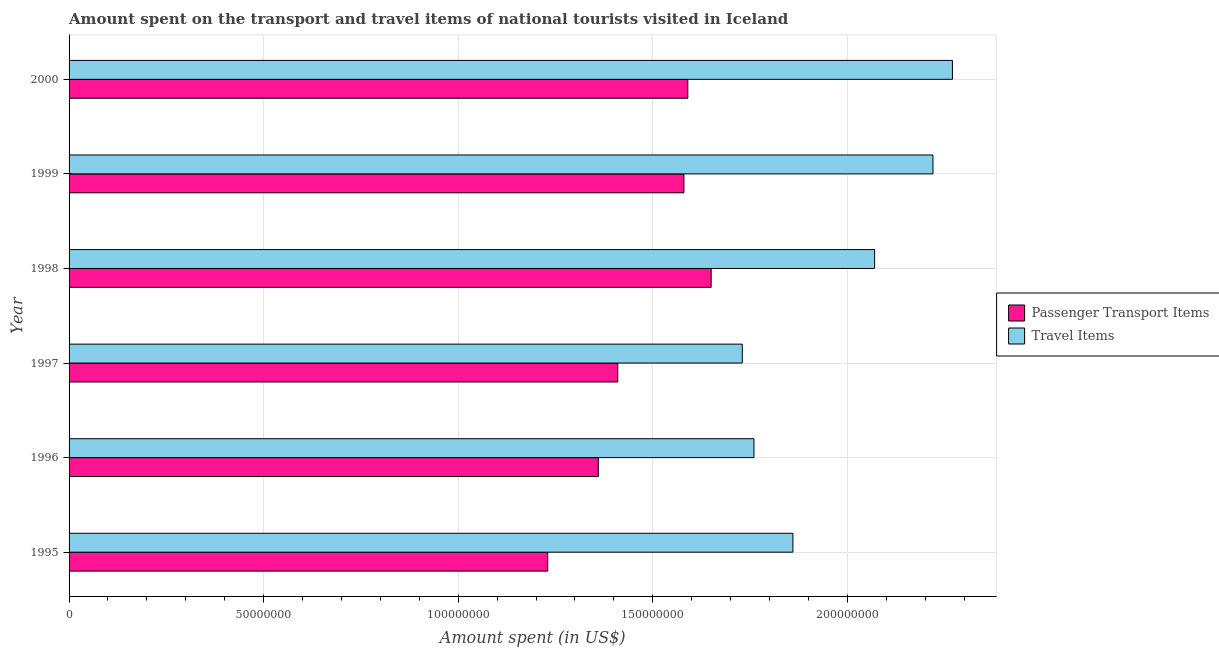How many different coloured bars are there?
Give a very brief answer. 2. Are the number of bars per tick equal to the number of legend labels?
Give a very brief answer. Yes. What is the label of the 1st group of bars from the top?
Your response must be concise. 2000. In how many cases, is the number of bars for a given year not equal to the number of legend labels?
Your answer should be compact. 0. What is the amount spent in travel items in 1997?
Provide a succinct answer. 1.73e+08. Across all years, what is the maximum amount spent in travel items?
Ensure brevity in your answer.  2.27e+08. Across all years, what is the minimum amount spent in travel items?
Make the answer very short. 1.73e+08. In which year was the amount spent in travel items maximum?
Provide a succinct answer. 2000. In which year was the amount spent on passenger transport items minimum?
Your answer should be compact. 1995. What is the total amount spent in travel items in the graph?
Your response must be concise. 1.19e+09. What is the difference between the amount spent in travel items in 1995 and that in 1999?
Provide a short and direct response. -3.60e+07. What is the difference between the amount spent in travel items in 1995 and the amount spent on passenger transport items in 1996?
Provide a short and direct response. 5.00e+07. What is the average amount spent on passenger transport items per year?
Offer a terse response. 1.47e+08. In the year 1995, what is the difference between the amount spent on passenger transport items and amount spent in travel items?
Give a very brief answer. -6.30e+07. In how many years, is the amount spent on passenger transport items greater than 70000000 US$?
Provide a succinct answer. 6. What is the ratio of the amount spent on passenger transport items in 1996 to that in 1999?
Keep it short and to the point. 0.86. Is the amount spent in travel items in 1999 less than that in 2000?
Provide a succinct answer. Yes. What is the difference between the highest and the second highest amount spent in travel items?
Offer a very short reply. 5.00e+06. What is the difference between the highest and the lowest amount spent in travel items?
Give a very brief answer. 5.40e+07. Is the sum of the amount spent on passenger transport items in 1995 and 1997 greater than the maximum amount spent in travel items across all years?
Make the answer very short. Yes. What does the 2nd bar from the top in 1995 represents?
Offer a terse response. Passenger Transport Items. What does the 2nd bar from the bottom in 1999 represents?
Your answer should be compact. Travel Items. Are all the bars in the graph horizontal?
Provide a short and direct response. Yes. Are the values on the major ticks of X-axis written in scientific E-notation?
Provide a short and direct response. No. Does the graph contain any zero values?
Provide a short and direct response. No. Does the graph contain grids?
Offer a very short reply. Yes. Where does the legend appear in the graph?
Provide a short and direct response. Center right. How many legend labels are there?
Ensure brevity in your answer.  2. How are the legend labels stacked?
Provide a succinct answer. Vertical. What is the title of the graph?
Give a very brief answer. Amount spent on the transport and travel items of national tourists visited in Iceland. What is the label or title of the X-axis?
Give a very brief answer. Amount spent (in US$). What is the Amount spent (in US$) of Passenger Transport Items in 1995?
Make the answer very short. 1.23e+08. What is the Amount spent (in US$) in Travel Items in 1995?
Your answer should be compact. 1.86e+08. What is the Amount spent (in US$) of Passenger Transport Items in 1996?
Offer a very short reply. 1.36e+08. What is the Amount spent (in US$) in Travel Items in 1996?
Your answer should be very brief. 1.76e+08. What is the Amount spent (in US$) in Passenger Transport Items in 1997?
Offer a terse response. 1.41e+08. What is the Amount spent (in US$) in Travel Items in 1997?
Provide a short and direct response. 1.73e+08. What is the Amount spent (in US$) in Passenger Transport Items in 1998?
Offer a very short reply. 1.65e+08. What is the Amount spent (in US$) in Travel Items in 1998?
Offer a very short reply. 2.07e+08. What is the Amount spent (in US$) of Passenger Transport Items in 1999?
Offer a terse response. 1.58e+08. What is the Amount spent (in US$) of Travel Items in 1999?
Ensure brevity in your answer.  2.22e+08. What is the Amount spent (in US$) of Passenger Transport Items in 2000?
Offer a very short reply. 1.59e+08. What is the Amount spent (in US$) of Travel Items in 2000?
Give a very brief answer. 2.27e+08. Across all years, what is the maximum Amount spent (in US$) in Passenger Transport Items?
Provide a short and direct response. 1.65e+08. Across all years, what is the maximum Amount spent (in US$) in Travel Items?
Provide a succinct answer. 2.27e+08. Across all years, what is the minimum Amount spent (in US$) of Passenger Transport Items?
Make the answer very short. 1.23e+08. Across all years, what is the minimum Amount spent (in US$) in Travel Items?
Your answer should be very brief. 1.73e+08. What is the total Amount spent (in US$) of Passenger Transport Items in the graph?
Offer a terse response. 8.82e+08. What is the total Amount spent (in US$) of Travel Items in the graph?
Keep it short and to the point. 1.19e+09. What is the difference between the Amount spent (in US$) of Passenger Transport Items in 1995 and that in 1996?
Make the answer very short. -1.30e+07. What is the difference between the Amount spent (in US$) of Travel Items in 1995 and that in 1996?
Make the answer very short. 1.00e+07. What is the difference between the Amount spent (in US$) of Passenger Transport Items in 1995 and that in 1997?
Provide a short and direct response. -1.80e+07. What is the difference between the Amount spent (in US$) in Travel Items in 1995 and that in 1997?
Keep it short and to the point. 1.30e+07. What is the difference between the Amount spent (in US$) of Passenger Transport Items in 1995 and that in 1998?
Your answer should be very brief. -4.20e+07. What is the difference between the Amount spent (in US$) of Travel Items in 1995 and that in 1998?
Offer a very short reply. -2.10e+07. What is the difference between the Amount spent (in US$) in Passenger Transport Items in 1995 and that in 1999?
Keep it short and to the point. -3.50e+07. What is the difference between the Amount spent (in US$) in Travel Items in 1995 and that in 1999?
Keep it short and to the point. -3.60e+07. What is the difference between the Amount spent (in US$) in Passenger Transport Items in 1995 and that in 2000?
Ensure brevity in your answer.  -3.60e+07. What is the difference between the Amount spent (in US$) of Travel Items in 1995 and that in 2000?
Your answer should be compact. -4.10e+07. What is the difference between the Amount spent (in US$) in Passenger Transport Items in 1996 and that in 1997?
Offer a terse response. -5.00e+06. What is the difference between the Amount spent (in US$) in Passenger Transport Items in 1996 and that in 1998?
Ensure brevity in your answer.  -2.90e+07. What is the difference between the Amount spent (in US$) of Travel Items in 1996 and that in 1998?
Give a very brief answer. -3.10e+07. What is the difference between the Amount spent (in US$) of Passenger Transport Items in 1996 and that in 1999?
Give a very brief answer. -2.20e+07. What is the difference between the Amount spent (in US$) in Travel Items in 1996 and that in 1999?
Keep it short and to the point. -4.60e+07. What is the difference between the Amount spent (in US$) of Passenger Transport Items in 1996 and that in 2000?
Your answer should be very brief. -2.30e+07. What is the difference between the Amount spent (in US$) in Travel Items in 1996 and that in 2000?
Your response must be concise. -5.10e+07. What is the difference between the Amount spent (in US$) in Passenger Transport Items in 1997 and that in 1998?
Offer a very short reply. -2.40e+07. What is the difference between the Amount spent (in US$) in Travel Items in 1997 and that in 1998?
Offer a terse response. -3.40e+07. What is the difference between the Amount spent (in US$) of Passenger Transport Items in 1997 and that in 1999?
Your answer should be very brief. -1.70e+07. What is the difference between the Amount spent (in US$) in Travel Items in 1997 and that in 1999?
Ensure brevity in your answer.  -4.90e+07. What is the difference between the Amount spent (in US$) in Passenger Transport Items in 1997 and that in 2000?
Make the answer very short. -1.80e+07. What is the difference between the Amount spent (in US$) of Travel Items in 1997 and that in 2000?
Make the answer very short. -5.40e+07. What is the difference between the Amount spent (in US$) of Passenger Transport Items in 1998 and that in 1999?
Offer a terse response. 7.00e+06. What is the difference between the Amount spent (in US$) of Travel Items in 1998 and that in 1999?
Make the answer very short. -1.50e+07. What is the difference between the Amount spent (in US$) of Passenger Transport Items in 1998 and that in 2000?
Your answer should be compact. 6.00e+06. What is the difference between the Amount spent (in US$) of Travel Items in 1998 and that in 2000?
Ensure brevity in your answer.  -2.00e+07. What is the difference between the Amount spent (in US$) in Travel Items in 1999 and that in 2000?
Ensure brevity in your answer.  -5.00e+06. What is the difference between the Amount spent (in US$) of Passenger Transport Items in 1995 and the Amount spent (in US$) of Travel Items in 1996?
Give a very brief answer. -5.30e+07. What is the difference between the Amount spent (in US$) in Passenger Transport Items in 1995 and the Amount spent (in US$) in Travel Items in 1997?
Your response must be concise. -5.00e+07. What is the difference between the Amount spent (in US$) in Passenger Transport Items in 1995 and the Amount spent (in US$) in Travel Items in 1998?
Your answer should be very brief. -8.40e+07. What is the difference between the Amount spent (in US$) of Passenger Transport Items in 1995 and the Amount spent (in US$) of Travel Items in 1999?
Make the answer very short. -9.90e+07. What is the difference between the Amount spent (in US$) in Passenger Transport Items in 1995 and the Amount spent (in US$) in Travel Items in 2000?
Offer a very short reply. -1.04e+08. What is the difference between the Amount spent (in US$) of Passenger Transport Items in 1996 and the Amount spent (in US$) of Travel Items in 1997?
Ensure brevity in your answer.  -3.70e+07. What is the difference between the Amount spent (in US$) of Passenger Transport Items in 1996 and the Amount spent (in US$) of Travel Items in 1998?
Your answer should be very brief. -7.10e+07. What is the difference between the Amount spent (in US$) of Passenger Transport Items in 1996 and the Amount spent (in US$) of Travel Items in 1999?
Offer a terse response. -8.60e+07. What is the difference between the Amount spent (in US$) in Passenger Transport Items in 1996 and the Amount spent (in US$) in Travel Items in 2000?
Your answer should be very brief. -9.10e+07. What is the difference between the Amount spent (in US$) of Passenger Transport Items in 1997 and the Amount spent (in US$) of Travel Items in 1998?
Make the answer very short. -6.60e+07. What is the difference between the Amount spent (in US$) of Passenger Transport Items in 1997 and the Amount spent (in US$) of Travel Items in 1999?
Make the answer very short. -8.10e+07. What is the difference between the Amount spent (in US$) in Passenger Transport Items in 1997 and the Amount spent (in US$) in Travel Items in 2000?
Give a very brief answer. -8.60e+07. What is the difference between the Amount spent (in US$) of Passenger Transport Items in 1998 and the Amount spent (in US$) of Travel Items in 1999?
Offer a very short reply. -5.70e+07. What is the difference between the Amount spent (in US$) of Passenger Transport Items in 1998 and the Amount spent (in US$) of Travel Items in 2000?
Keep it short and to the point. -6.20e+07. What is the difference between the Amount spent (in US$) in Passenger Transport Items in 1999 and the Amount spent (in US$) in Travel Items in 2000?
Offer a terse response. -6.90e+07. What is the average Amount spent (in US$) in Passenger Transport Items per year?
Provide a succinct answer. 1.47e+08. What is the average Amount spent (in US$) of Travel Items per year?
Keep it short and to the point. 1.98e+08. In the year 1995, what is the difference between the Amount spent (in US$) of Passenger Transport Items and Amount spent (in US$) of Travel Items?
Make the answer very short. -6.30e+07. In the year 1996, what is the difference between the Amount spent (in US$) in Passenger Transport Items and Amount spent (in US$) in Travel Items?
Your response must be concise. -4.00e+07. In the year 1997, what is the difference between the Amount spent (in US$) in Passenger Transport Items and Amount spent (in US$) in Travel Items?
Your answer should be compact. -3.20e+07. In the year 1998, what is the difference between the Amount spent (in US$) of Passenger Transport Items and Amount spent (in US$) of Travel Items?
Your answer should be very brief. -4.20e+07. In the year 1999, what is the difference between the Amount spent (in US$) in Passenger Transport Items and Amount spent (in US$) in Travel Items?
Offer a terse response. -6.40e+07. In the year 2000, what is the difference between the Amount spent (in US$) in Passenger Transport Items and Amount spent (in US$) in Travel Items?
Keep it short and to the point. -6.80e+07. What is the ratio of the Amount spent (in US$) of Passenger Transport Items in 1995 to that in 1996?
Provide a succinct answer. 0.9. What is the ratio of the Amount spent (in US$) in Travel Items in 1995 to that in 1996?
Give a very brief answer. 1.06. What is the ratio of the Amount spent (in US$) in Passenger Transport Items in 1995 to that in 1997?
Give a very brief answer. 0.87. What is the ratio of the Amount spent (in US$) of Travel Items in 1995 to that in 1997?
Keep it short and to the point. 1.08. What is the ratio of the Amount spent (in US$) in Passenger Transport Items in 1995 to that in 1998?
Offer a very short reply. 0.75. What is the ratio of the Amount spent (in US$) of Travel Items in 1995 to that in 1998?
Your answer should be compact. 0.9. What is the ratio of the Amount spent (in US$) in Passenger Transport Items in 1995 to that in 1999?
Make the answer very short. 0.78. What is the ratio of the Amount spent (in US$) of Travel Items in 1995 to that in 1999?
Give a very brief answer. 0.84. What is the ratio of the Amount spent (in US$) of Passenger Transport Items in 1995 to that in 2000?
Offer a very short reply. 0.77. What is the ratio of the Amount spent (in US$) of Travel Items in 1995 to that in 2000?
Offer a terse response. 0.82. What is the ratio of the Amount spent (in US$) of Passenger Transport Items in 1996 to that in 1997?
Offer a very short reply. 0.96. What is the ratio of the Amount spent (in US$) in Travel Items in 1996 to that in 1997?
Provide a succinct answer. 1.02. What is the ratio of the Amount spent (in US$) in Passenger Transport Items in 1996 to that in 1998?
Give a very brief answer. 0.82. What is the ratio of the Amount spent (in US$) of Travel Items in 1996 to that in 1998?
Provide a succinct answer. 0.85. What is the ratio of the Amount spent (in US$) of Passenger Transport Items in 1996 to that in 1999?
Your answer should be very brief. 0.86. What is the ratio of the Amount spent (in US$) of Travel Items in 1996 to that in 1999?
Provide a short and direct response. 0.79. What is the ratio of the Amount spent (in US$) of Passenger Transport Items in 1996 to that in 2000?
Offer a very short reply. 0.86. What is the ratio of the Amount spent (in US$) of Travel Items in 1996 to that in 2000?
Provide a short and direct response. 0.78. What is the ratio of the Amount spent (in US$) of Passenger Transport Items in 1997 to that in 1998?
Your answer should be very brief. 0.85. What is the ratio of the Amount spent (in US$) of Travel Items in 1997 to that in 1998?
Ensure brevity in your answer.  0.84. What is the ratio of the Amount spent (in US$) in Passenger Transport Items in 1997 to that in 1999?
Ensure brevity in your answer.  0.89. What is the ratio of the Amount spent (in US$) of Travel Items in 1997 to that in 1999?
Offer a terse response. 0.78. What is the ratio of the Amount spent (in US$) in Passenger Transport Items in 1997 to that in 2000?
Your response must be concise. 0.89. What is the ratio of the Amount spent (in US$) in Travel Items in 1997 to that in 2000?
Provide a succinct answer. 0.76. What is the ratio of the Amount spent (in US$) in Passenger Transport Items in 1998 to that in 1999?
Make the answer very short. 1.04. What is the ratio of the Amount spent (in US$) in Travel Items in 1998 to that in 1999?
Your answer should be compact. 0.93. What is the ratio of the Amount spent (in US$) in Passenger Transport Items in 1998 to that in 2000?
Make the answer very short. 1.04. What is the ratio of the Amount spent (in US$) in Travel Items in 1998 to that in 2000?
Offer a very short reply. 0.91. What is the difference between the highest and the lowest Amount spent (in US$) in Passenger Transport Items?
Your response must be concise. 4.20e+07. What is the difference between the highest and the lowest Amount spent (in US$) of Travel Items?
Give a very brief answer. 5.40e+07. 